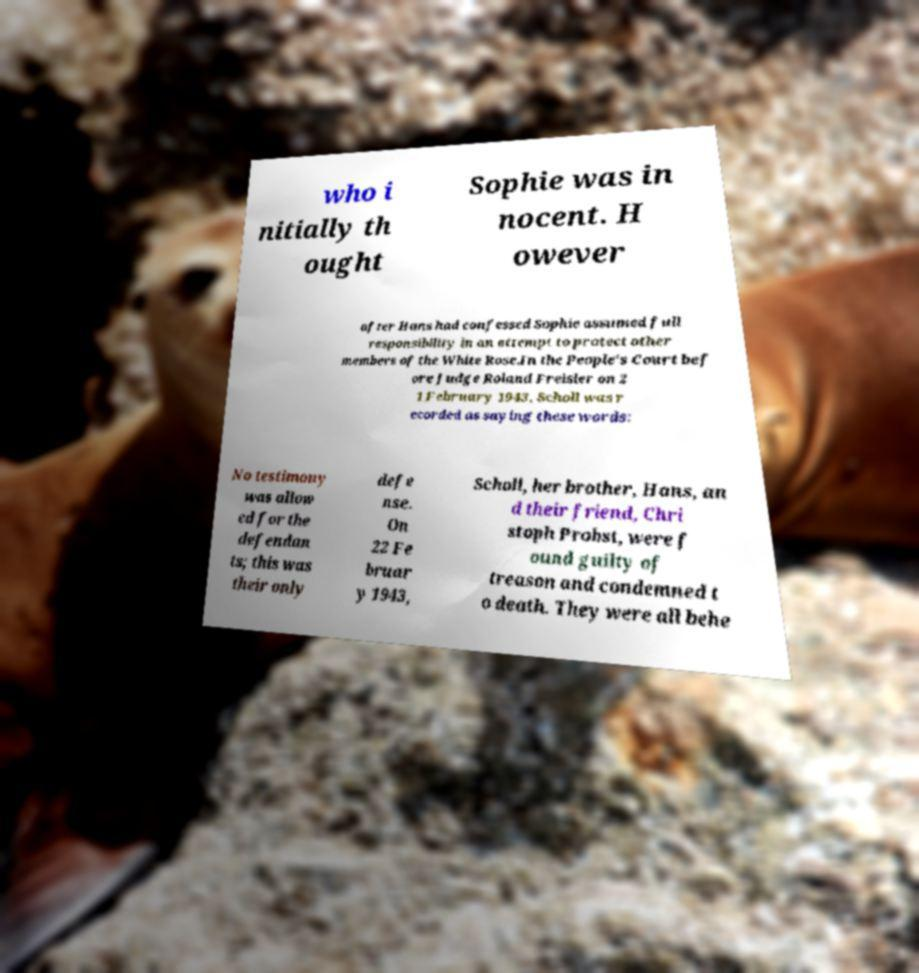Could you extract and type out the text from this image? who i nitially th ought Sophie was in nocent. H owever after Hans had confessed Sophie assumed full responsibility in an attempt to protect other members of the White Rose.In the People's Court bef ore Judge Roland Freisler on 2 1 February 1943, Scholl was r ecorded as saying these words: No testimony was allow ed for the defendan ts; this was their only defe nse. On 22 Fe bruar y 1943, Scholl, her brother, Hans, an d their friend, Chri stoph Probst, were f ound guilty of treason and condemned t o death. They were all behe 